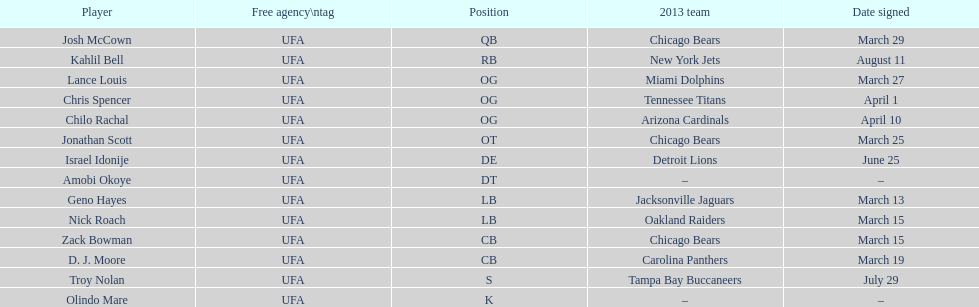Which other player was signed concurrently with nick roach? Zack Bowman. 